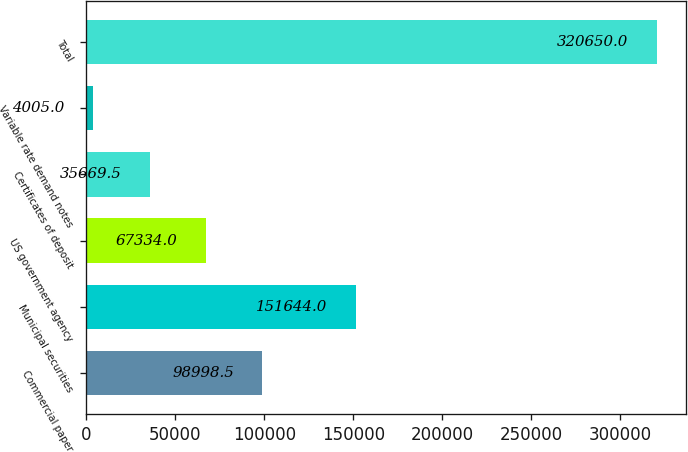<chart> <loc_0><loc_0><loc_500><loc_500><bar_chart><fcel>Commercial paper<fcel>Municipal securities<fcel>US government agency<fcel>Certificates of deposit<fcel>Variable rate demand notes<fcel>Total<nl><fcel>98998.5<fcel>151644<fcel>67334<fcel>35669.5<fcel>4005<fcel>320650<nl></chart> 